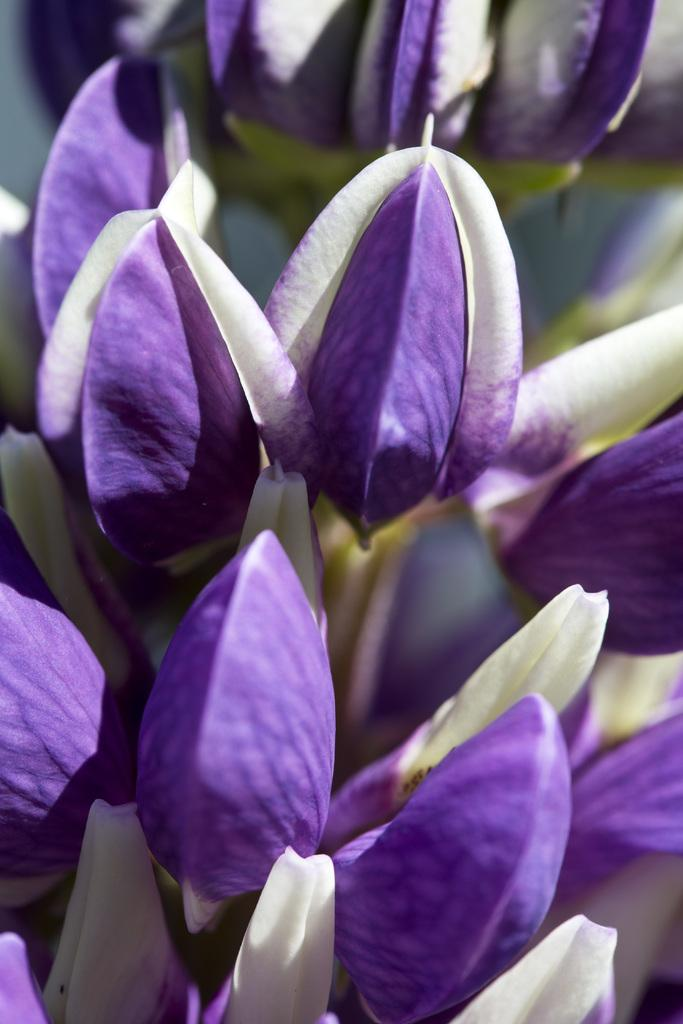What type of living organisms can be seen in the image? Flowers can be seen in the image. Can you describe the flowers in the image? Unfortunately, the facts provided do not give specific details about the flowers. What might be the purpose of the flowers in the image? The purpose of the flowers in the image cannot be determined from the given facts. How many berries are present on the flowers in the image? There are no berries mentioned or visible in the image; it only contains flowers. 